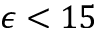<formula> <loc_0><loc_0><loc_500><loc_500>\epsilon < 1 5</formula> 